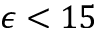<formula> <loc_0><loc_0><loc_500><loc_500>\epsilon < 1 5</formula> 